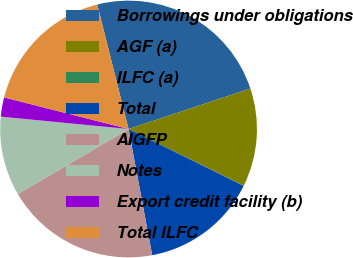Convert chart to OTSL. <chart><loc_0><loc_0><loc_500><loc_500><pie_chart><fcel>Borrowings under obligations<fcel>AGF (a)<fcel>ILFC (a)<fcel>Total<fcel>AIGFP<fcel>Notes<fcel>Export credit facility (b)<fcel>Total ILFC<nl><fcel>23.82%<fcel>12.37%<fcel>0.04%<fcel>14.75%<fcel>19.5%<fcel>9.99%<fcel>2.42%<fcel>17.12%<nl></chart> 